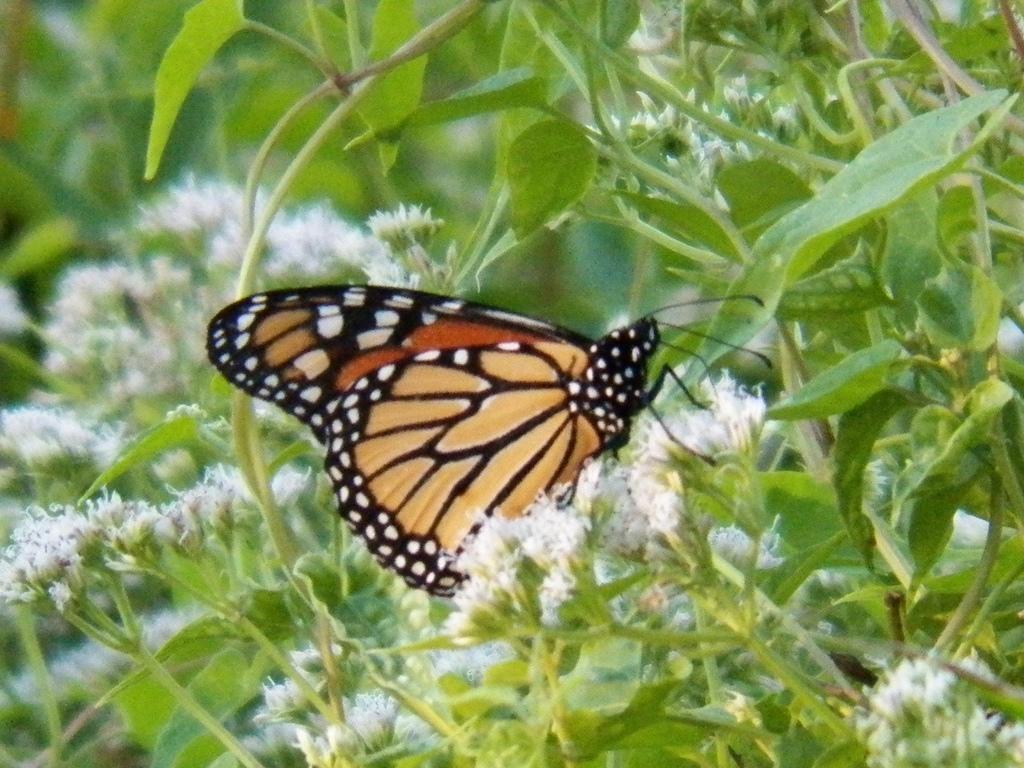Describe this image in one or two sentences. This image consists of a butterfly sitting on the flowers. There are white color flowers along with plants and trees. 